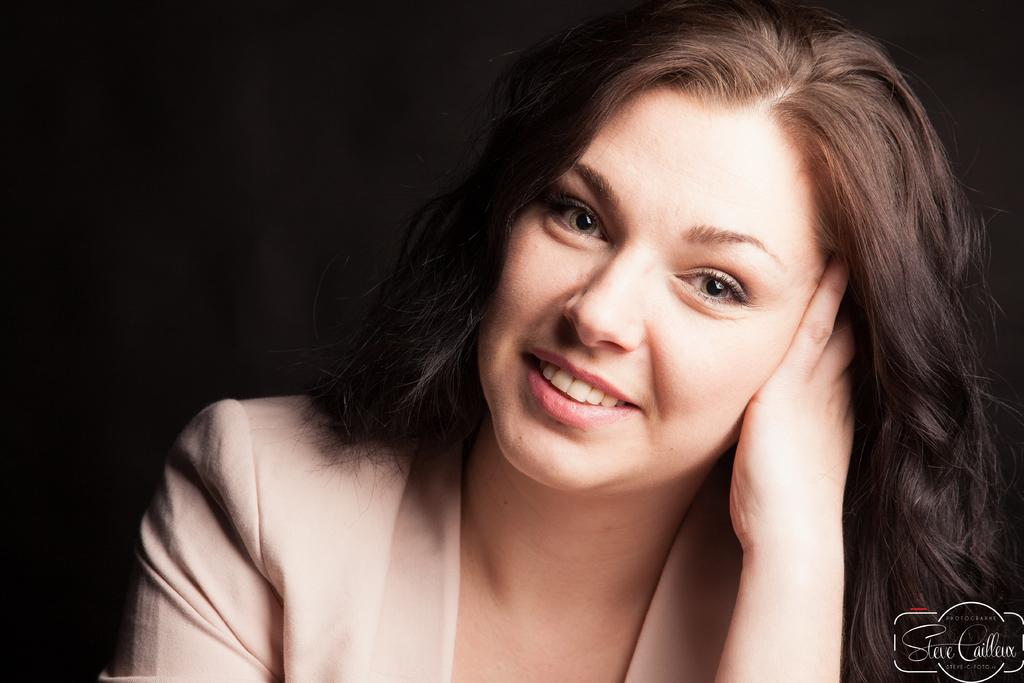Who is the main subject in the image? There is a lady in the image. What can be observed about the background of the image? The background of the image is dark. Are there any words or letters visible in the image? Yes, there is text visible on the image. What type of key is being used to open the pan in the image? There is no key or pan present in the image. 